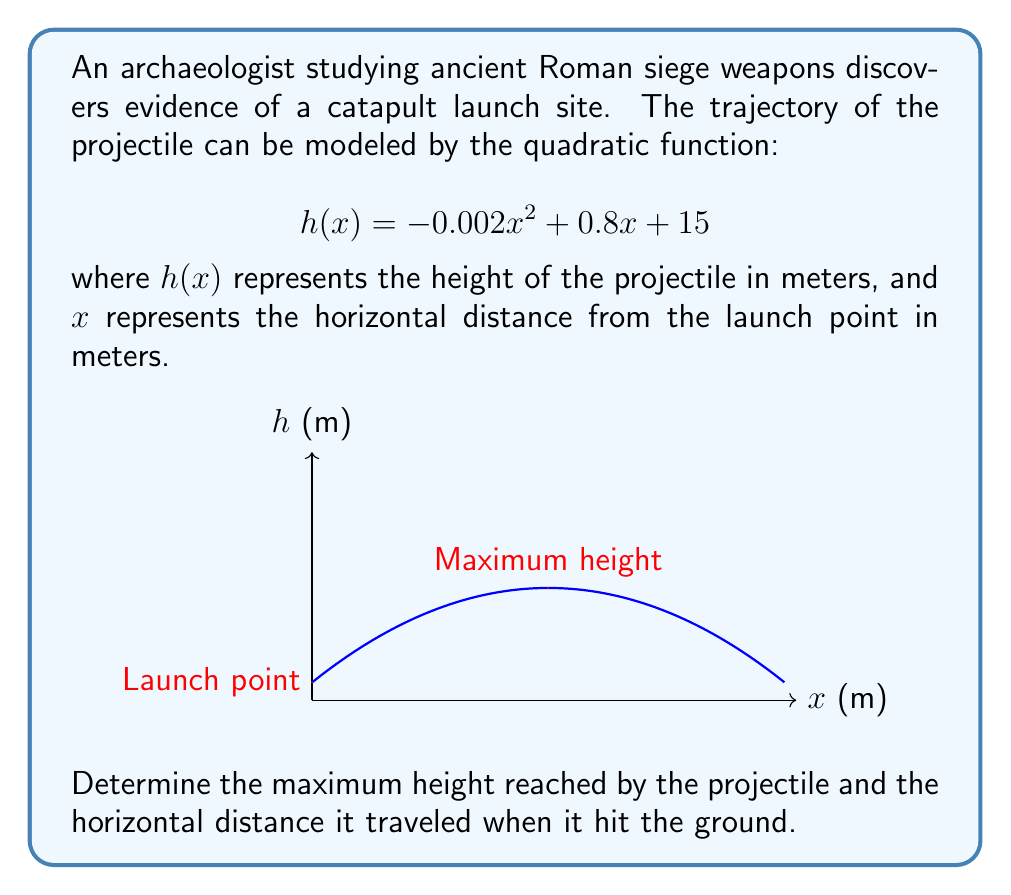Can you answer this question? Let's approach this step-by-step:

1) To find the maximum height, we need to find the vertex of the parabola. For a quadratic function in the form $f(x) = ax^2 + bx + c$, the x-coordinate of the vertex is given by $x = -\frac{b}{2a}$.

2) In our function, $a = -0.002$, $b = 0.8$, and $c = 15$. Let's calculate the x-coordinate of the vertex:

   $$x = -\frac{0.8}{2(-0.002)} = 200$$

3) To find the maximum height, we substitute this x-value into our original function:

   $$h(200) = -0.002(200)^2 + 0.8(200) + 15$$
   $$= -80 + 160 + 15 = 95$$

   So, the maximum height is 95 meters, occurring 200 meters horizontally from the launch point.

4) To find where the projectile hits the ground, we need to solve the equation $h(x) = 0$:

   $$-0.002x^2 + 0.8x + 15 = 0$$

5) This is a quadratic equation. We can solve it using the quadratic formula: $x = \frac{-b \pm \sqrt{b^2 - 4ac}}{2a}$

   $$x = \frac{-0.8 \pm \sqrt{0.8^2 - 4(-0.002)(15)}}{2(-0.002)}$$

6) Simplifying:

   $$x = \frac{-0.8 \pm \sqrt{0.64 + 0.12}}{-0.004} = \frac{-0.8 \pm \sqrt{0.76}}{-0.004}$$
   $$x = \frac{-0.8 \pm 0.8718}{-0.004}$$

7) This gives us two solutions:
   $$x_1 = \frac{-0.8 + 0.8718}{-0.004} \approx 17.95$$
   $$x_2 = \frac{-0.8 - 0.8718}{-0.004} \approx 417.95$$

8) The negative solution (17.95) doesn't make sense in this context, so we take the positive solution. The projectile hits the ground approximately 417.95 meters from the launch point.
Answer: Maximum height: 95 m; Horizontal distance traveled: 417.95 m 